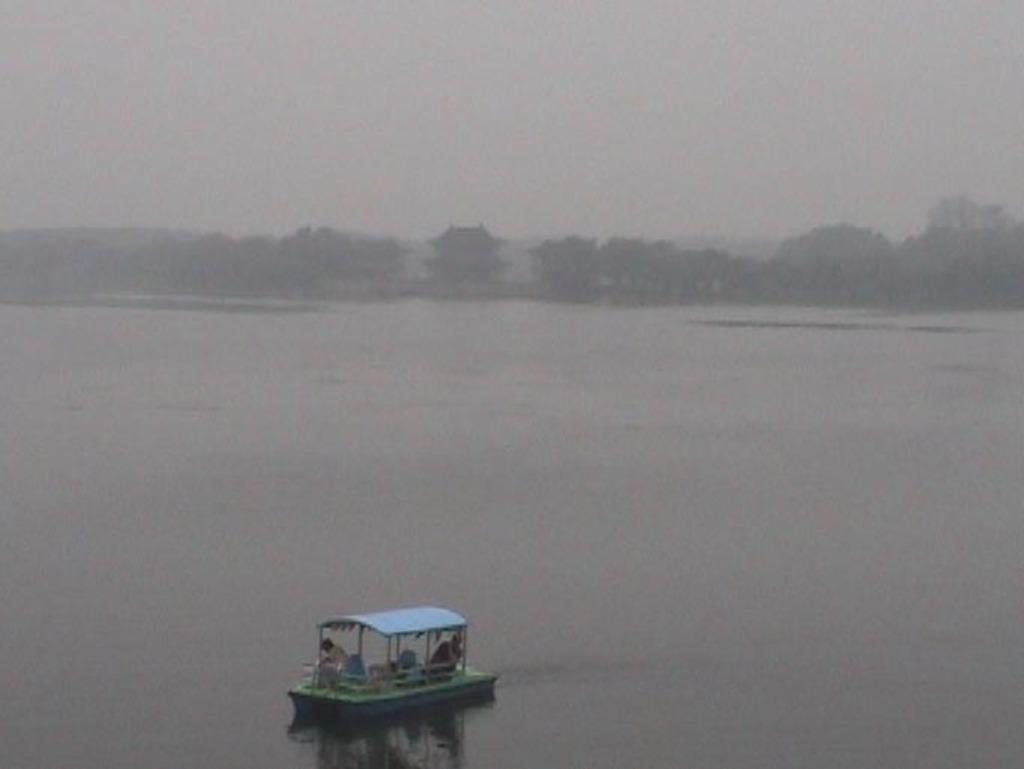What is located at the bottom of the image? There is a boat in the water at the bottom of the image. Who or what is inside the boat? There are people in the boat. What can be seen in the background of the image? There are trees visible in the background of the image. What type of spoon is being used by the secretary in the image? There is no secretary or spoon present in the image. 